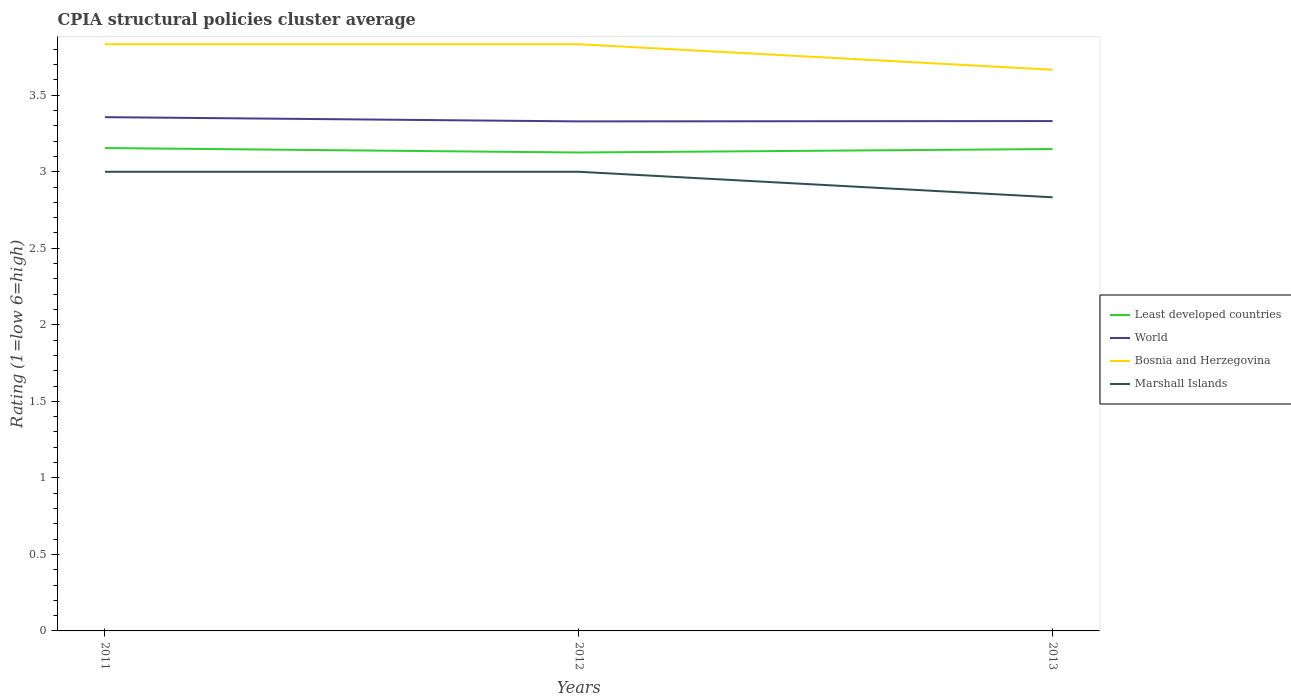How many different coloured lines are there?
Your answer should be compact. 4. Does the line corresponding to Least developed countries intersect with the line corresponding to World?
Offer a terse response. No. Across all years, what is the maximum CPIA rating in Bosnia and Herzegovina?
Your answer should be very brief. 3.67. In which year was the CPIA rating in Bosnia and Herzegovina maximum?
Your response must be concise. 2013. What is the total CPIA rating in World in the graph?
Offer a terse response. -0. What is the difference between the highest and the second highest CPIA rating in World?
Make the answer very short. 0.03. What is the difference between the highest and the lowest CPIA rating in Least developed countries?
Ensure brevity in your answer.  2. How many years are there in the graph?
Provide a succinct answer. 3. What is the difference between two consecutive major ticks on the Y-axis?
Provide a succinct answer. 0.5. Are the values on the major ticks of Y-axis written in scientific E-notation?
Your response must be concise. No. Does the graph contain any zero values?
Your answer should be very brief. No. How many legend labels are there?
Your response must be concise. 4. What is the title of the graph?
Your answer should be very brief. CPIA structural policies cluster average. Does "Turkey" appear as one of the legend labels in the graph?
Provide a short and direct response. No. What is the label or title of the X-axis?
Your answer should be compact. Years. What is the label or title of the Y-axis?
Your answer should be very brief. Rating (1=low 6=high). What is the Rating (1=low 6=high) of Least developed countries in 2011?
Offer a terse response. 3.16. What is the Rating (1=low 6=high) of World in 2011?
Your response must be concise. 3.36. What is the Rating (1=low 6=high) in Bosnia and Herzegovina in 2011?
Offer a terse response. 3.83. What is the Rating (1=low 6=high) of Least developed countries in 2012?
Your answer should be compact. 3.13. What is the Rating (1=low 6=high) of World in 2012?
Offer a terse response. 3.33. What is the Rating (1=low 6=high) of Bosnia and Herzegovina in 2012?
Give a very brief answer. 3.83. What is the Rating (1=low 6=high) of Marshall Islands in 2012?
Make the answer very short. 3. What is the Rating (1=low 6=high) in Least developed countries in 2013?
Offer a terse response. 3.15. What is the Rating (1=low 6=high) in World in 2013?
Offer a very short reply. 3.33. What is the Rating (1=low 6=high) in Bosnia and Herzegovina in 2013?
Make the answer very short. 3.67. What is the Rating (1=low 6=high) of Marshall Islands in 2013?
Your response must be concise. 2.83. Across all years, what is the maximum Rating (1=low 6=high) of Least developed countries?
Provide a succinct answer. 3.16. Across all years, what is the maximum Rating (1=low 6=high) of World?
Provide a succinct answer. 3.36. Across all years, what is the maximum Rating (1=low 6=high) of Bosnia and Herzegovina?
Ensure brevity in your answer.  3.83. Across all years, what is the maximum Rating (1=low 6=high) in Marshall Islands?
Provide a short and direct response. 3. Across all years, what is the minimum Rating (1=low 6=high) of Least developed countries?
Give a very brief answer. 3.13. Across all years, what is the minimum Rating (1=low 6=high) in World?
Provide a succinct answer. 3.33. Across all years, what is the minimum Rating (1=low 6=high) in Bosnia and Herzegovina?
Your answer should be compact. 3.67. Across all years, what is the minimum Rating (1=low 6=high) of Marshall Islands?
Ensure brevity in your answer.  2.83. What is the total Rating (1=low 6=high) of Least developed countries in the graph?
Offer a terse response. 9.43. What is the total Rating (1=low 6=high) in World in the graph?
Your response must be concise. 10.02. What is the total Rating (1=low 6=high) of Bosnia and Herzegovina in the graph?
Give a very brief answer. 11.33. What is the total Rating (1=low 6=high) in Marshall Islands in the graph?
Provide a succinct answer. 8.83. What is the difference between the Rating (1=low 6=high) of Least developed countries in 2011 and that in 2012?
Your response must be concise. 0.03. What is the difference between the Rating (1=low 6=high) of World in 2011 and that in 2012?
Provide a succinct answer. 0.03. What is the difference between the Rating (1=low 6=high) of Bosnia and Herzegovina in 2011 and that in 2012?
Ensure brevity in your answer.  0. What is the difference between the Rating (1=low 6=high) of Marshall Islands in 2011 and that in 2012?
Offer a very short reply. 0. What is the difference between the Rating (1=low 6=high) of Least developed countries in 2011 and that in 2013?
Make the answer very short. 0.01. What is the difference between the Rating (1=low 6=high) in World in 2011 and that in 2013?
Keep it short and to the point. 0.03. What is the difference between the Rating (1=low 6=high) in Bosnia and Herzegovina in 2011 and that in 2013?
Give a very brief answer. 0.17. What is the difference between the Rating (1=low 6=high) of Marshall Islands in 2011 and that in 2013?
Provide a short and direct response. 0.17. What is the difference between the Rating (1=low 6=high) of Least developed countries in 2012 and that in 2013?
Provide a short and direct response. -0.02. What is the difference between the Rating (1=low 6=high) of World in 2012 and that in 2013?
Give a very brief answer. -0. What is the difference between the Rating (1=low 6=high) in Bosnia and Herzegovina in 2012 and that in 2013?
Your answer should be very brief. 0.17. What is the difference between the Rating (1=low 6=high) of Marshall Islands in 2012 and that in 2013?
Offer a terse response. 0.17. What is the difference between the Rating (1=low 6=high) in Least developed countries in 2011 and the Rating (1=low 6=high) in World in 2012?
Give a very brief answer. -0.17. What is the difference between the Rating (1=low 6=high) in Least developed countries in 2011 and the Rating (1=low 6=high) in Bosnia and Herzegovina in 2012?
Your answer should be very brief. -0.68. What is the difference between the Rating (1=low 6=high) in Least developed countries in 2011 and the Rating (1=low 6=high) in Marshall Islands in 2012?
Offer a terse response. 0.15. What is the difference between the Rating (1=low 6=high) in World in 2011 and the Rating (1=low 6=high) in Bosnia and Herzegovina in 2012?
Make the answer very short. -0.48. What is the difference between the Rating (1=low 6=high) in World in 2011 and the Rating (1=low 6=high) in Marshall Islands in 2012?
Keep it short and to the point. 0.36. What is the difference between the Rating (1=low 6=high) of Bosnia and Herzegovina in 2011 and the Rating (1=low 6=high) of Marshall Islands in 2012?
Provide a short and direct response. 0.83. What is the difference between the Rating (1=low 6=high) in Least developed countries in 2011 and the Rating (1=low 6=high) in World in 2013?
Make the answer very short. -0.18. What is the difference between the Rating (1=low 6=high) in Least developed countries in 2011 and the Rating (1=low 6=high) in Bosnia and Herzegovina in 2013?
Provide a succinct answer. -0.51. What is the difference between the Rating (1=low 6=high) in Least developed countries in 2011 and the Rating (1=low 6=high) in Marshall Islands in 2013?
Give a very brief answer. 0.32. What is the difference between the Rating (1=low 6=high) in World in 2011 and the Rating (1=low 6=high) in Bosnia and Herzegovina in 2013?
Keep it short and to the point. -0.31. What is the difference between the Rating (1=low 6=high) in World in 2011 and the Rating (1=low 6=high) in Marshall Islands in 2013?
Offer a very short reply. 0.52. What is the difference between the Rating (1=low 6=high) in Least developed countries in 2012 and the Rating (1=low 6=high) in World in 2013?
Provide a short and direct response. -0.21. What is the difference between the Rating (1=low 6=high) in Least developed countries in 2012 and the Rating (1=low 6=high) in Bosnia and Herzegovina in 2013?
Provide a succinct answer. -0.54. What is the difference between the Rating (1=low 6=high) of Least developed countries in 2012 and the Rating (1=low 6=high) of Marshall Islands in 2013?
Your answer should be compact. 0.29. What is the difference between the Rating (1=low 6=high) of World in 2012 and the Rating (1=low 6=high) of Bosnia and Herzegovina in 2013?
Your answer should be compact. -0.34. What is the difference between the Rating (1=low 6=high) in World in 2012 and the Rating (1=low 6=high) in Marshall Islands in 2013?
Give a very brief answer. 0.5. What is the average Rating (1=low 6=high) in Least developed countries per year?
Make the answer very short. 3.14. What is the average Rating (1=low 6=high) of World per year?
Your answer should be very brief. 3.34. What is the average Rating (1=low 6=high) in Bosnia and Herzegovina per year?
Your answer should be very brief. 3.78. What is the average Rating (1=low 6=high) of Marshall Islands per year?
Offer a very short reply. 2.94. In the year 2011, what is the difference between the Rating (1=low 6=high) in Least developed countries and Rating (1=low 6=high) in World?
Give a very brief answer. -0.2. In the year 2011, what is the difference between the Rating (1=low 6=high) in Least developed countries and Rating (1=low 6=high) in Bosnia and Herzegovina?
Make the answer very short. -0.68. In the year 2011, what is the difference between the Rating (1=low 6=high) in Least developed countries and Rating (1=low 6=high) in Marshall Islands?
Ensure brevity in your answer.  0.15. In the year 2011, what is the difference between the Rating (1=low 6=high) in World and Rating (1=low 6=high) in Bosnia and Herzegovina?
Your answer should be compact. -0.48. In the year 2011, what is the difference between the Rating (1=low 6=high) in World and Rating (1=low 6=high) in Marshall Islands?
Keep it short and to the point. 0.36. In the year 2012, what is the difference between the Rating (1=low 6=high) in Least developed countries and Rating (1=low 6=high) in World?
Provide a succinct answer. -0.2. In the year 2012, what is the difference between the Rating (1=low 6=high) in Least developed countries and Rating (1=low 6=high) in Bosnia and Herzegovina?
Keep it short and to the point. -0.71. In the year 2012, what is the difference between the Rating (1=low 6=high) in Least developed countries and Rating (1=low 6=high) in Marshall Islands?
Ensure brevity in your answer.  0.13. In the year 2012, what is the difference between the Rating (1=low 6=high) of World and Rating (1=low 6=high) of Bosnia and Herzegovina?
Offer a terse response. -0.5. In the year 2012, what is the difference between the Rating (1=low 6=high) of World and Rating (1=low 6=high) of Marshall Islands?
Offer a very short reply. 0.33. In the year 2013, what is the difference between the Rating (1=low 6=high) of Least developed countries and Rating (1=low 6=high) of World?
Give a very brief answer. -0.18. In the year 2013, what is the difference between the Rating (1=low 6=high) in Least developed countries and Rating (1=low 6=high) in Bosnia and Herzegovina?
Provide a succinct answer. -0.52. In the year 2013, what is the difference between the Rating (1=low 6=high) of Least developed countries and Rating (1=low 6=high) of Marshall Islands?
Keep it short and to the point. 0.32. In the year 2013, what is the difference between the Rating (1=low 6=high) of World and Rating (1=low 6=high) of Bosnia and Herzegovina?
Your answer should be very brief. -0.34. In the year 2013, what is the difference between the Rating (1=low 6=high) of World and Rating (1=low 6=high) of Marshall Islands?
Your response must be concise. 0.5. What is the ratio of the Rating (1=low 6=high) of Least developed countries in 2011 to that in 2012?
Offer a terse response. 1.01. What is the ratio of the Rating (1=low 6=high) of World in 2011 to that in 2012?
Give a very brief answer. 1.01. What is the ratio of the Rating (1=low 6=high) of Bosnia and Herzegovina in 2011 to that in 2012?
Give a very brief answer. 1. What is the ratio of the Rating (1=low 6=high) of Marshall Islands in 2011 to that in 2012?
Provide a short and direct response. 1. What is the ratio of the Rating (1=low 6=high) of World in 2011 to that in 2013?
Make the answer very short. 1.01. What is the ratio of the Rating (1=low 6=high) of Bosnia and Herzegovina in 2011 to that in 2013?
Your response must be concise. 1.05. What is the ratio of the Rating (1=low 6=high) of Marshall Islands in 2011 to that in 2013?
Make the answer very short. 1.06. What is the ratio of the Rating (1=low 6=high) of Least developed countries in 2012 to that in 2013?
Your response must be concise. 0.99. What is the ratio of the Rating (1=low 6=high) of Bosnia and Herzegovina in 2012 to that in 2013?
Offer a very short reply. 1.05. What is the ratio of the Rating (1=low 6=high) in Marshall Islands in 2012 to that in 2013?
Your answer should be very brief. 1.06. What is the difference between the highest and the second highest Rating (1=low 6=high) of Least developed countries?
Keep it short and to the point. 0.01. What is the difference between the highest and the second highest Rating (1=low 6=high) of World?
Your answer should be very brief. 0.03. What is the difference between the highest and the second highest Rating (1=low 6=high) in Bosnia and Herzegovina?
Keep it short and to the point. 0. What is the difference between the highest and the second highest Rating (1=low 6=high) of Marshall Islands?
Your answer should be compact. 0. What is the difference between the highest and the lowest Rating (1=low 6=high) of Least developed countries?
Keep it short and to the point. 0.03. What is the difference between the highest and the lowest Rating (1=low 6=high) in World?
Make the answer very short. 0.03. 